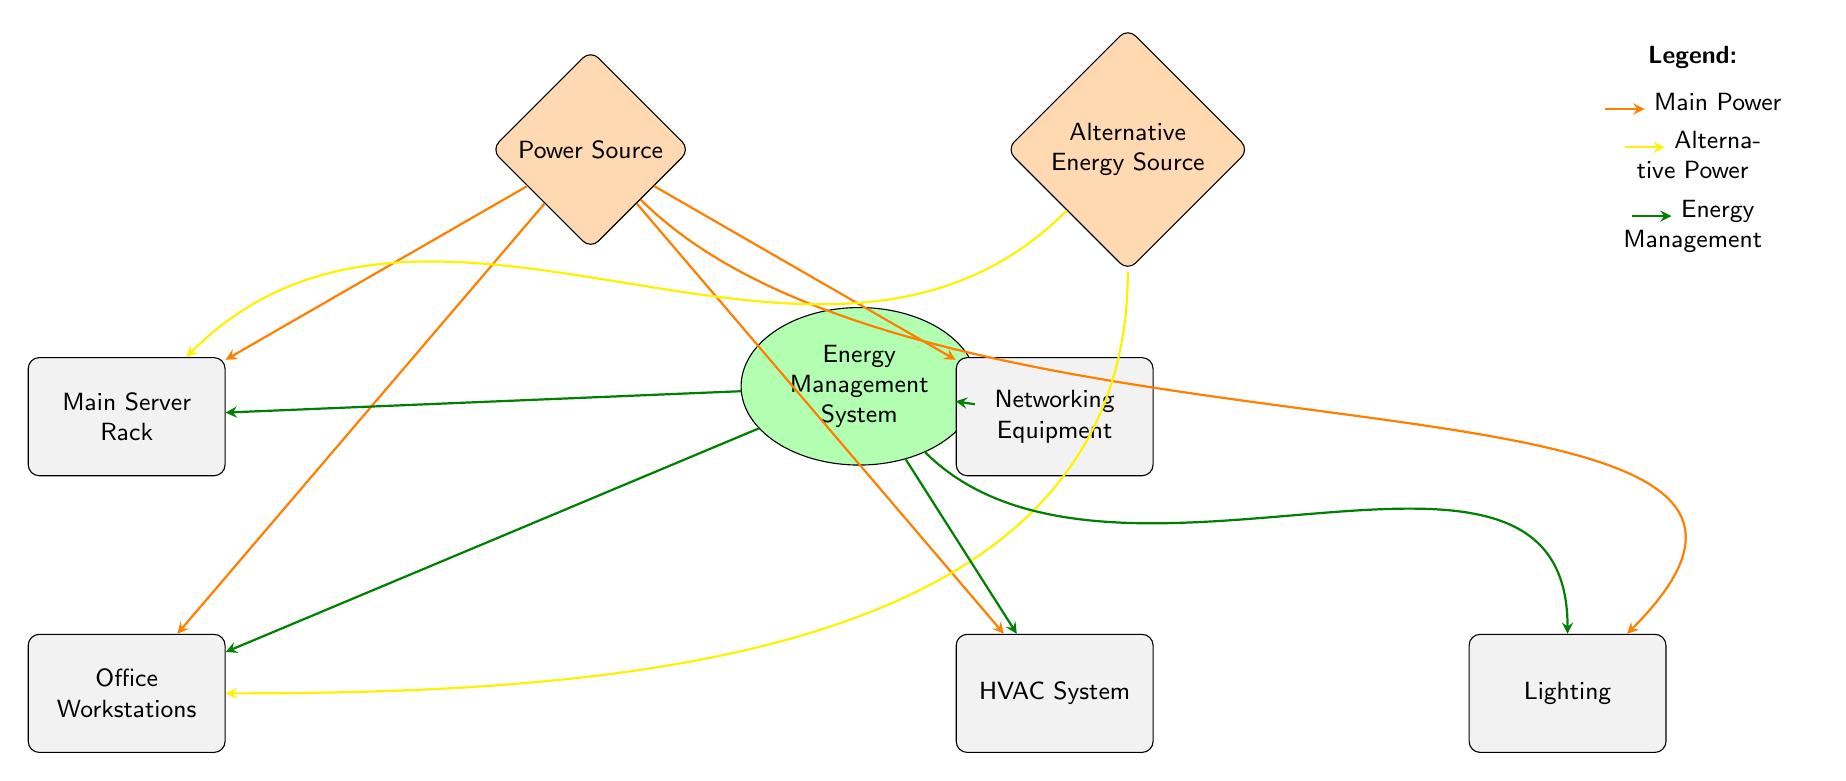What are the two types of power sources shown? The diagram mentions two power sources: the Main Power Source and the Alternative Energy Source. Both are labeled clearly at the top of the diagram.
Answer: Main Power Source and Alternative Energy Source How many types of equipment are powered by the main power source? The main power source connects directly to five pieces of equipment: Main Server Rack, Office Workstations, Networking Equipment, HVAC System, and Lighting. Therefore, there are five types of equipment powered by it.
Answer: Five What type of system influences the energy flow to all components shown? The Energy Management System is represented in the diagram and is connected to all the primary equipment, indicating its role in managing energy flow.
Answer: Energy Management System Which equipment receives power from both the main power and alternative energy sources? The Main Server Rack and Office Workstations are the only components that receive power from both sources as seen from the connections in the diagram to these nodes.
Answer: Main Server Rack and Office Workstations How does the alternative energy source interact with the HVAC system? The diagram shows no direct connection between the alternative energy source and the HVAC system; thus, it does not interact. The HVAC system only connects to the main power and the Energy Management System.
Answer: No interaction What color represents the Energy Management System connections? The connections from the Energy Management System in the diagram are colored green, indicating it manages energy flow to all connected equipment.
Answer: Green How are the connections from the alternative energy source differentiated from the main power source? The connections from the alternative energy source are represented by yellow arrows, while the main power source connections are shown with orange arrows, clearly differentiating the two.
Answer: Yellow arrows Which component is furthest right in the diagram? The Lighting component is positioned furthest to the right in the layout of the diagram. This can be identified by tracing the horizontal arrangement of the nodes.
Answer: Lighting 